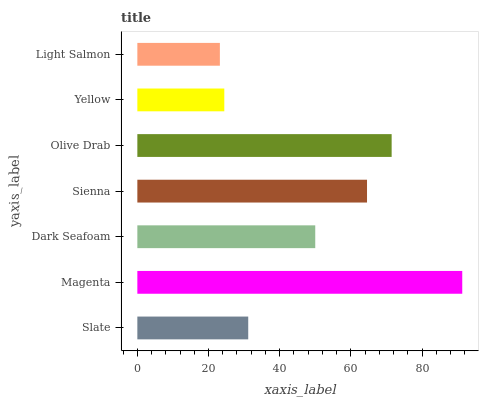Is Light Salmon the minimum?
Answer yes or no. Yes. Is Magenta the maximum?
Answer yes or no. Yes. Is Dark Seafoam the minimum?
Answer yes or no. No. Is Dark Seafoam the maximum?
Answer yes or no. No. Is Magenta greater than Dark Seafoam?
Answer yes or no. Yes. Is Dark Seafoam less than Magenta?
Answer yes or no. Yes. Is Dark Seafoam greater than Magenta?
Answer yes or no. No. Is Magenta less than Dark Seafoam?
Answer yes or no. No. Is Dark Seafoam the high median?
Answer yes or no. Yes. Is Dark Seafoam the low median?
Answer yes or no. Yes. Is Magenta the high median?
Answer yes or no. No. Is Sienna the low median?
Answer yes or no. No. 